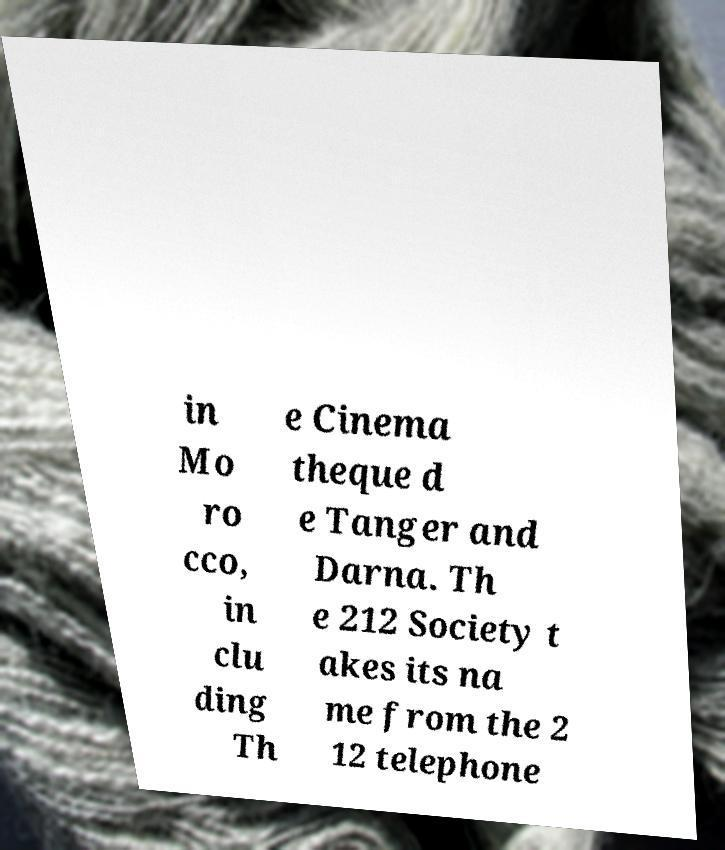Could you extract and type out the text from this image? in Mo ro cco, in clu ding Th e Cinema theque d e Tanger and Darna. Th e 212 Society t akes its na me from the 2 12 telephone 